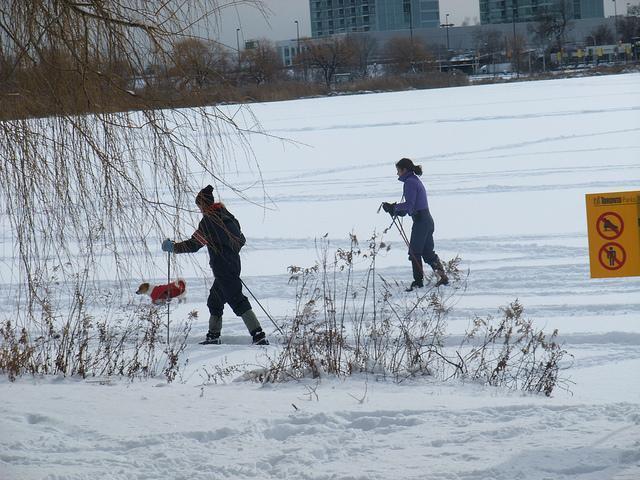How many people are there?
Give a very brief answer. 2. 